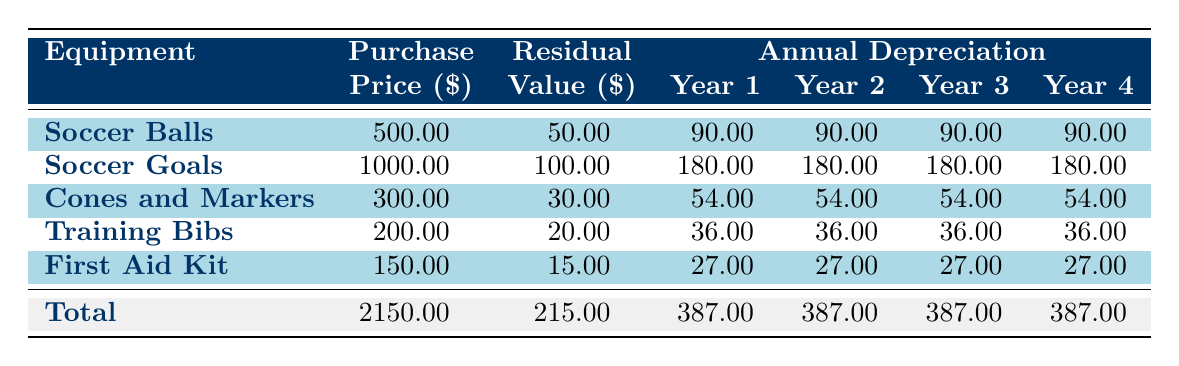What is the purchase price of the Soccer Goals? The table directly states that the purchase price for the Soccer Goals is listed under the "Purchase Price ($)" column. The corresponding value for Soccer Goals is 1000.00.
Answer: 1000.00 What is the residual value of the First Aid Kit? The residual value for the First Aid Kit can be found in the "Residual Value ($)" column, which shows that it is 15.00.
Answer: 15.00 Which item has the highest annual depreciation in Year 1? The table shows the annual depreciation values for Year 1. Comparing all values, Soccer Goals has the highest depreciation at 180.00.
Answer: Soccer Goals What is the total depreciation for all items in Year 4? To find the total depreciation for Year 4, we need to sum the values for each item from the "Annual Depreciation" column for Year 4. This is calculated as: 90.00 (Soccer Balls) + 180.00 (Soccer Goals) + 54.00 (Cones and Markers) + 36.00 (Training Bibs) + 27.00 (First Aid Kit) = 387.00.
Answer: 387.00 Is it true that the total purchase price of all equipment is less than 2500? The total purchase price is listed under the "Total" row in the "Purchase Price ($)" column as 2150.00, which is indeed less than 2500.
Answer: Yes 